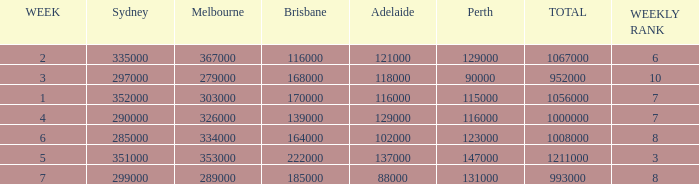How many viewers were there in Sydney for the episode when there were 334000 in Melbourne? 285000.0. 